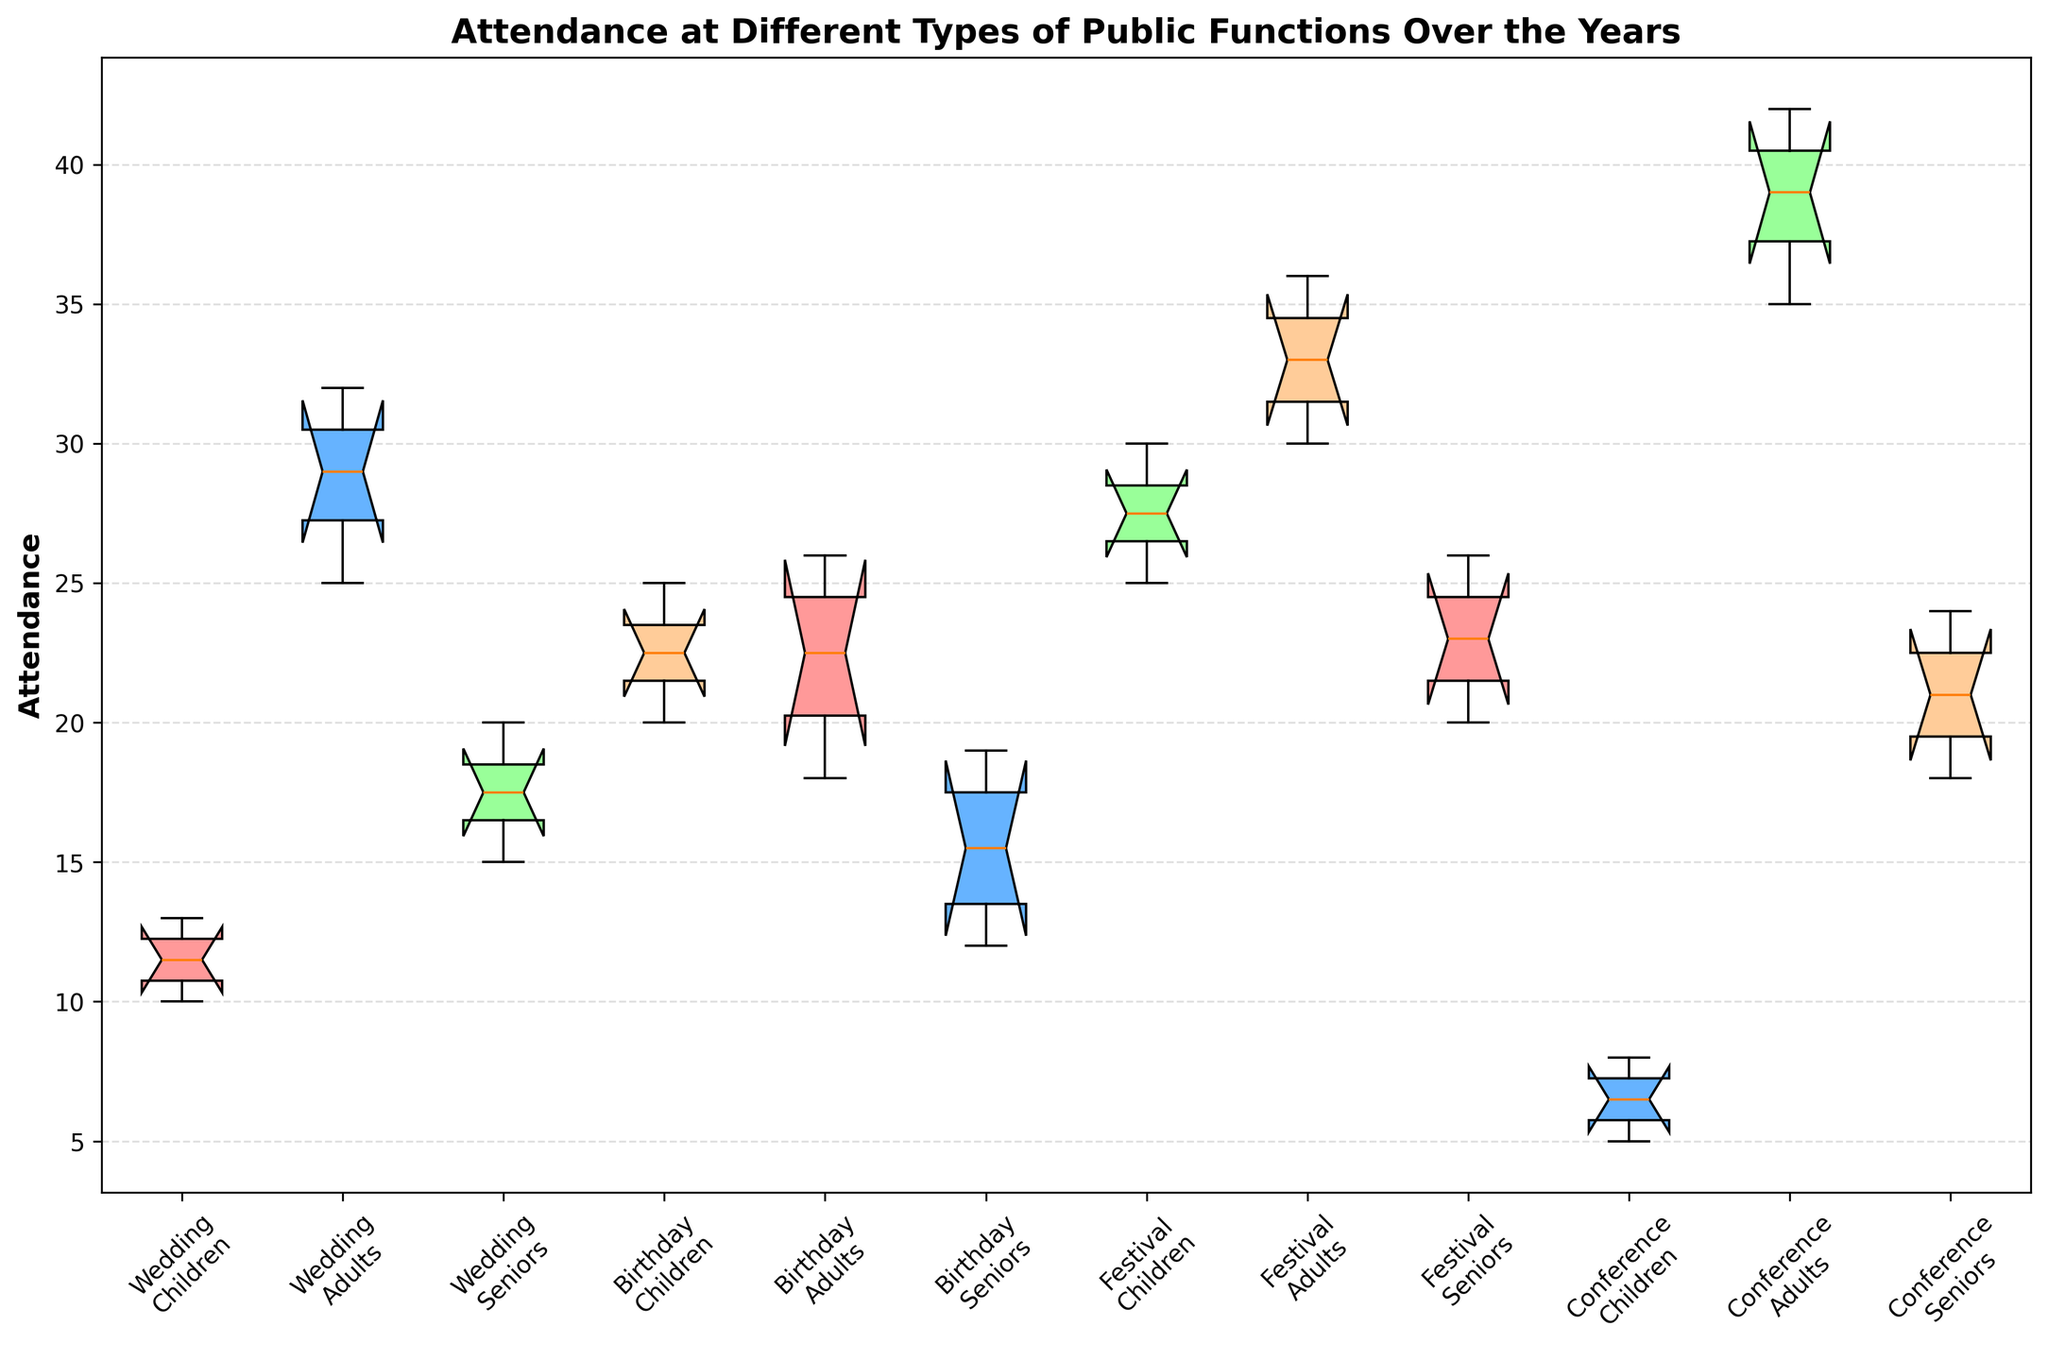Which age group has the highest median attendance at Festivals? Identify the Festival event category and then compare the median lines within the Children's, Adults', and Seniors' box plots for Festivals.
Answer: Adults How does the variability in attendance for Conferences compare between Children and Adults? Look at the length of the boxes (interquartile range) for Conferences in both Children and Adults groups. A longer box indicates higher variability.
Answer: Adults show higher variability What is the median attendance for Weddings among Seniors? Find the Wedding event category and identify the box for Seniors. The median is the line inside the box.
Answer: 18 Which event type has the least attendance variability among Children? Compare the width of the box plots for Children across all event types. The smaller the interquartile range (IQR), the less variability there is.
Answer: Conferences Is the median attendance for Adults at Conferences greater than that for Seniors at the same events? Compare the median lines for Adults and Seniors in the Conference event category.
Answer: Yes Which age group and event type combination has the highest overall attendance? Identify the group with the highest median value among all combinations. The tallest median line is the highest attendance.
Answer: Adults at Festivals Does the attendance for Birthday events among Children increase or decrease over the years? Assess the position of the box plots for Children in the Birthday category across different years by looking at the overall trend of the box plots positions.
Answer: Increase For which event type is the difference between the highest and lowest attendance among Adults the greatest? Look at the range (maximum - minimum) within each box plot for Adults across different event types. Identify the one with the maximum spread.
Answer: Conferences What is the trend for attendance among Seniors at Festivals over the years? Observe the changes in the position of the box plots for Seniors in the Festival category across the years. The general positioning trend indicates the answer.
Answer: Increase 